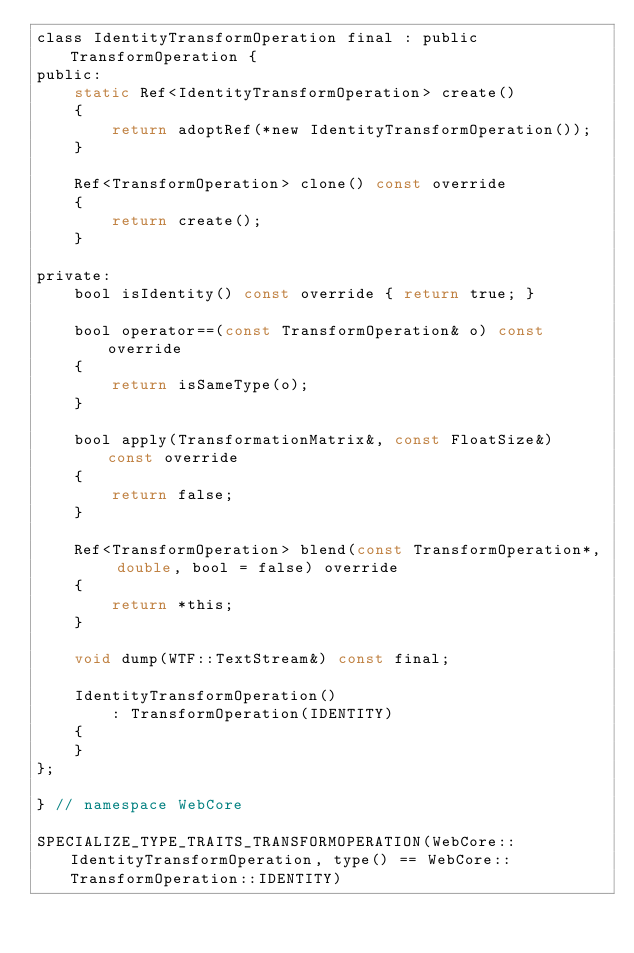Convert code to text. <code><loc_0><loc_0><loc_500><loc_500><_C_>class IdentityTransformOperation final : public TransformOperation {
public:
    static Ref<IdentityTransformOperation> create()
    {
        return adoptRef(*new IdentityTransformOperation());
    }

    Ref<TransformOperation> clone() const override
    {
        return create();
    }

private:
    bool isIdentity() const override { return true; }

    bool operator==(const TransformOperation& o) const override
    {
        return isSameType(o);
    }

    bool apply(TransformationMatrix&, const FloatSize&) const override
    {
        return false;
    }

    Ref<TransformOperation> blend(const TransformOperation*, double, bool = false) override
    {
        return *this;
    }

    void dump(WTF::TextStream&) const final;

    IdentityTransformOperation()
        : TransformOperation(IDENTITY)
    {
    }
};

} // namespace WebCore

SPECIALIZE_TYPE_TRAITS_TRANSFORMOPERATION(WebCore::IdentityTransformOperation, type() == WebCore::TransformOperation::IDENTITY)
</code> 